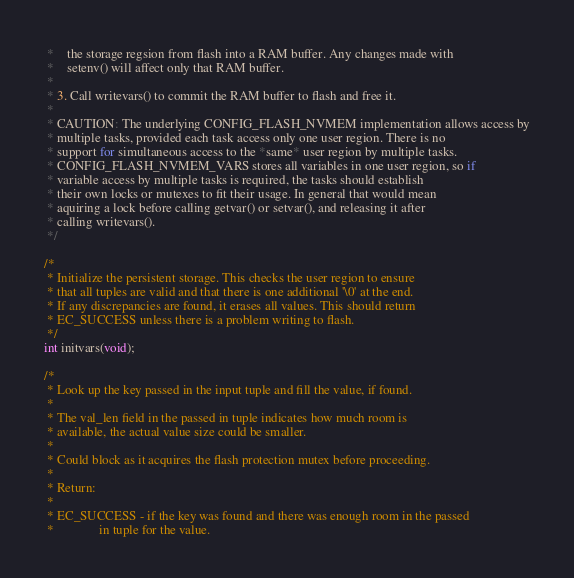<code> <loc_0><loc_0><loc_500><loc_500><_C_> *    the storage regsion from flash into a RAM buffer. Any changes made with
 *    setenv() will affect only that RAM buffer.
 *
 * 3. Call writevars() to commit the RAM buffer to flash and free it.
 *
 * CAUTION: The underlying CONFIG_FLASH_NVMEM implementation allows access by
 * multiple tasks, provided each task access only one user region. There is no
 * support for simultaneous access to the *same* user region by multiple tasks.
 * CONFIG_FLASH_NVMEM_VARS stores all variables in one user region, so if
 * variable access by multiple tasks is required, the tasks should establish
 * their own locks or mutexes to fit their usage. In general that would mean
 * aquiring a lock before calling getvar() or setvar(), and releasing it after
 * calling writevars().
 */

/*
 * Initialize the persistent storage. This checks the user region to ensure
 * that all tuples are valid and that there is one additional '\0' at the end.
 * If any discrepancies are found, it erases all values. This should return
 * EC_SUCCESS unless there is a problem writing to flash.
 */
int initvars(void);

/*
 * Look up the key passed in the input tuple and fill the value, if found.
 *
 * The val_len field in the passed in tuple indicates how much room is
 * available, the actual value size could be smaller.
 *
 * Could block as it acquires the flash protection mutex before proceeding.
 *
 * Return:
 *
 * EC_SUCCESS - if the key was found and there was enough room in the passed
 *              in tuple for the value.</code> 